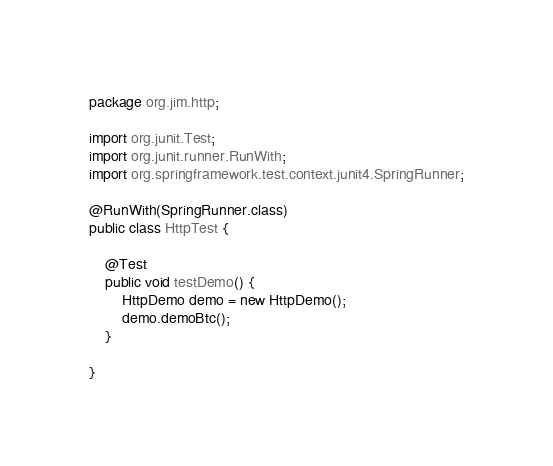<code> <loc_0><loc_0><loc_500><loc_500><_Java_>package org.jim.http;

import org.junit.Test;
import org.junit.runner.RunWith;
import org.springframework.test.context.junit4.SpringRunner;

@RunWith(SpringRunner.class)
public class HttpTest {

    @Test
    public void testDemo() {
        HttpDemo demo = new HttpDemo();
        demo.demoBtc();
    }

}
</code> 